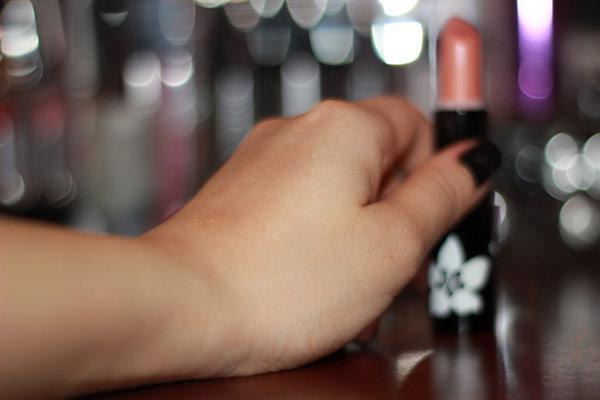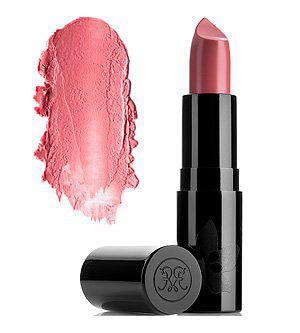The first image is the image on the left, the second image is the image on the right. For the images shown, is this caption "An image shows one upright tube lipstick next to its horizontal cap and a smear of color." true? Answer yes or no. Yes. The first image is the image on the left, the second image is the image on the right. Given the left and right images, does the statement "The image on the right has a lipstick smudge on the left side of a single tube of lipstick." hold true? Answer yes or no. Yes. 